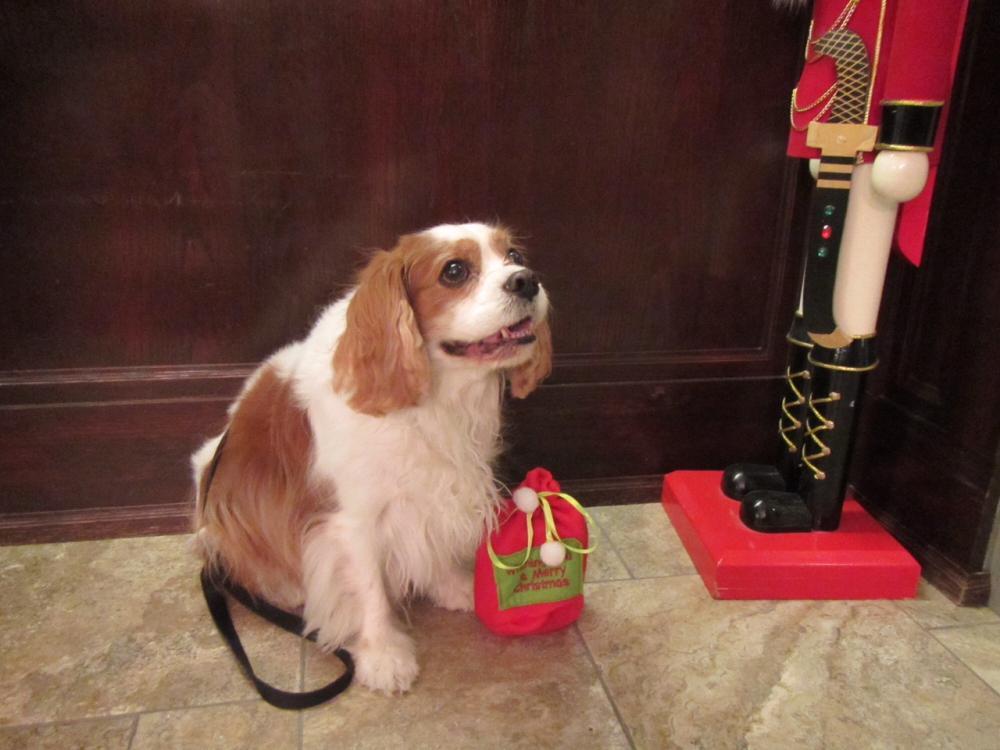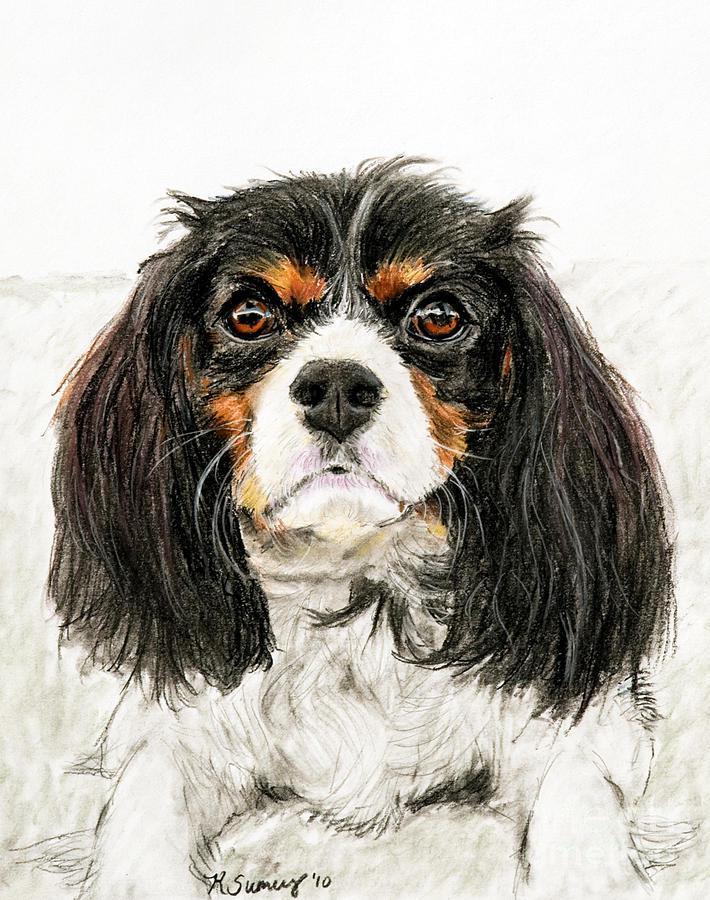The first image is the image on the left, the second image is the image on the right. Considering the images on both sides, is "There are 2 dogs." valid? Answer yes or no. Yes. The first image is the image on the left, the second image is the image on the right. Analyze the images presented: Is the assertion "Each image depicts a single spaniel dog, and the dogs on the right and left have different fur coloring." valid? Answer yes or no. Yes. 